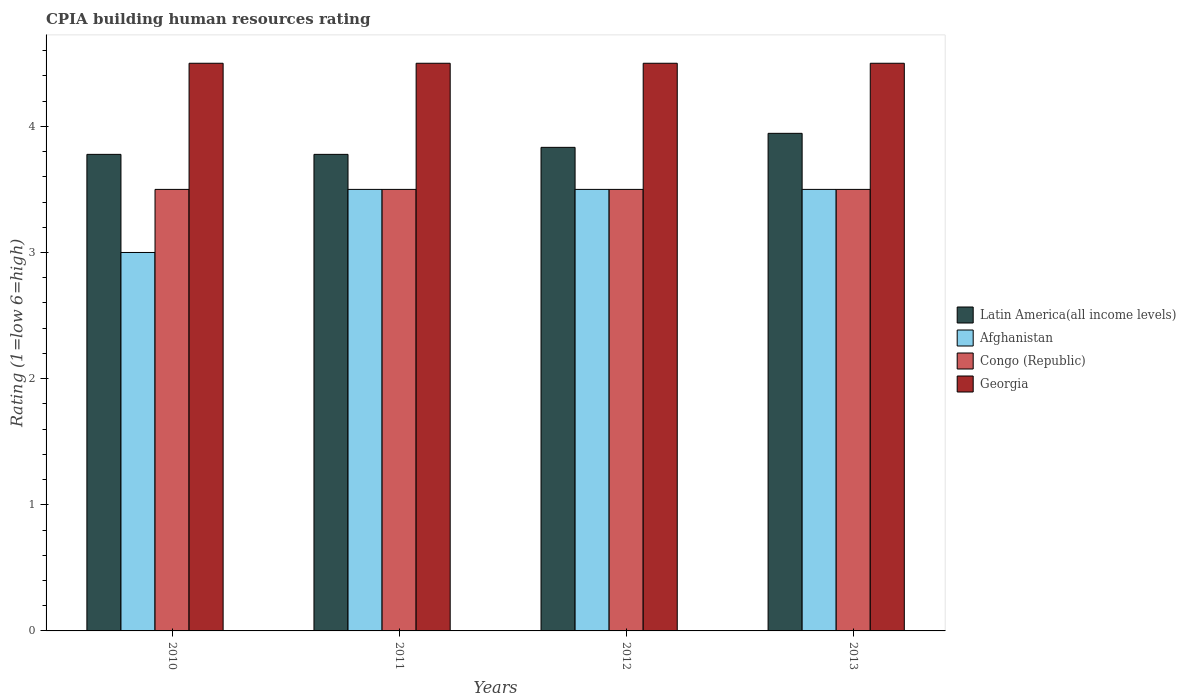What is the label of the 2nd group of bars from the left?
Ensure brevity in your answer.  2011. What is the CPIA rating in Afghanistan in 2012?
Provide a succinct answer. 3.5. Across all years, what is the maximum CPIA rating in Georgia?
Make the answer very short. 4.5. In which year was the CPIA rating in Latin America(all income levels) minimum?
Provide a succinct answer. 2010. What is the difference between the CPIA rating in Afghanistan in 2010 and the CPIA rating in Congo (Republic) in 2012?
Give a very brief answer. -0.5. What is the average CPIA rating in Afghanistan per year?
Keep it short and to the point. 3.38. In the year 2012, what is the difference between the CPIA rating in Latin America(all income levels) and CPIA rating in Congo (Republic)?
Your response must be concise. 0.33. In how many years, is the CPIA rating in Georgia greater than 4.2?
Offer a terse response. 4. What is the ratio of the CPIA rating in Congo (Republic) in 2011 to that in 2013?
Make the answer very short. 1. Is the CPIA rating in Congo (Republic) in 2012 less than that in 2013?
Your answer should be very brief. No. What is the difference between the highest and the lowest CPIA rating in Georgia?
Offer a terse response. 0. Is the sum of the CPIA rating in Georgia in 2012 and 2013 greater than the maximum CPIA rating in Congo (Republic) across all years?
Your answer should be compact. Yes. What does the 4th bar from the left in 2010 represents?
Provide a succinct answer. Georgia. What does the 1st bar from the right in 2013 represents?
Make the answer very short. Georgia. How many bars are there?
Your response must be concise. 16. Are all the bars in the graph horizontal?
Ensure brevity in your answer.  No. How many years are there in the graph?
Keep it short and to the point. 4. Does the graph contain any zero values?
Provide a short and direct response. No. How are the legend labels stacked?
Offer a terse response. Vertical. What is the title of the graph?
Your response must be concise. CPIA building human resources rating. Does "Russian Federation" appear as one of the legend labels in the graph?
Keep it short and to the point. No. What is the Rating (1=low 6=high) in Latin America(all income levels) in 2010?
Keep it short and to the point. 3.78. What is the Rating (1=low 6=high) in Congo (Republic) in 2010?
Provide a short and direct response. 3.5. What is the Rating (1=low 6=high) in Latin America(all income levels) in 2011?
Provide a succinct answer. 3.78. What is the Rating (1=low 6=high) of Georgia in 2011?
Offer a terse response. 4.5. What is the Rating (1=low 6=high) in Latin America(all income levels) in 2012?
Make the answer very short. 3.83. What is the Rating (1=low 6=high) in Georgia in 2012?
Your answer should be very brief. 4.5. What is the Rating (1=low 6=high) in Latin America(all income levels) in 2013?
Keep it short and to the point. 3.94. What is the Rating (1=low 6=high) in Afghanistan in 2013?
Make the answer very short. 3.5. Across all years, what is the maximum Rating (1=low 6=high) in Latin America(all income levels)?
Your response must be concise. 3.94. Across all years, what is the maximum Rating (1=low 6=high) of Afghanistan?
Provide a succinct answer. 3.5. Across all years, what is the maximum Rating (1=low 6=high) of Congo (Republic)?
Ensure brevity in your answer.  3.5. Across all years, what is the maximum Rating (1=low 6=high) of Georgia?
Your answer should be very brief. 4.5. Across all years, what is the minimum Rating (1=low 6=high) of Latin America(all income levels)?
Your answer should be compact. 3.78. Across all years, what is the minimum Rating (1=low 6=high) in Afghanistan?
Make the answer very short. 3. Across all years, what is the minimum Rating (1=low 6=high) of Congo (Republic)?
Your answer should be compact. 3.5. Across all years, what is the minimum Rating (1=low 6=high) of Georgia?
Keep it short and to the point. 4.5. What is the total Rating (1=low 6=high) in Latin America(all income levels) in the graph?
Make the answer very short. 15.33. What is the total Rating (1=low 6=high) in Afghanistan in the graph?
Your answer should be very brief. 13.5. What is the difference between the Rating (1=low 6=high) in Latin America(all income levels) in 2010 and that in 2011?
Offer a very short reply. 0. What is the difference between the Rating (1=low 6=high) in Afghanistan in 2010 and that in 2011?
Provide a succinct answer. -0.5. What is the difference between the Rating (1=low 6=high) of Latin America(all income levels) in 2010 and that in 2012?
Your answer should be very brief. -0.06. What is the difference between the Rating (1=low 6=high) in Afghanistan in 2010 and that in 2012?
Your response must be concise. -0.5. What is the difference between the Rating (1=low 6=high) in Georgia in 2010 and that in 2012?
Give a very brief answer. 0. What is the difference between the Rating (1=low 6=high) in Latin America(all income levels) in 2010 and that in 2013?
Give a very brief answer. -0.17. What is the difference between the Rating (1=low 6=high) of Afghanistan in 2010 and that in 2013?
Provide a short and direct response. -0.5. What is the difference between the Rating (1=low 6=high) of Georgia in 2010 and that in 2013?
Your response must be concise. 0. What is the difference between the Rating (1=low 6=high) of Latin America(all income levels) in 2011 and that in 2012?
Offer a very short reply. -0.06. What is the difference between the Rating (1=low 6=high) in Afghanistan in 2011 and that in 2012?
Your answer should be very brief. 0. What is the difference between the Rating (1=low 6=high) in Congo (Republic) in 2011 and that in 2012?
Your answer should be very brief. 0. What is the difference between the Rating (1=low 6=high) of Latin America(all income levels) in 2011 and that in 2013?
Ensure brevity in your answer.  -0.17. What is the difference between the Rating (1=low 6=high) of Congo (Republic) in 2011 and that in 2013?
Your answer should be compact. 0. What is the difference between the Rating (1=low 6=high) of Georgia in 2011 and that in 2013?
Make the answer very short. 0. What is the difference between the Rating (1=low 6=high) in Latin America(all income levels) in 2012 and that in 2013?
Ensure brevity in your answer.  -0.11. What is the difference between the Rating (1=low 6=high) of Afghanistan in 2012 and that in 2013?
Your response must be concise. 0. What is the difference between the Rating (1=low 6=high) in Latin America(all income levels) in 2010 and the Rating (1=low 6=high) in Afghanistan in 2011?
Give a very brief answer. 0.28. What is the difference between the Rating (1=low 6=high) in Latin America(all income levels) in 2010 and the Rating (1=low 6=high) in Congo (Republic) in 2011?
Provide a short and direct response. 0.28. What is the difference between the Rating (1=low 6=high) in Latin America(all income levels) in 2010 and the Rating (1=low 6=high) in Georgia in 2011?
Keep it short and to the point. -0.72. What is the difference between the Rating (1=low 6=high) in Afghanistan in 2010 and the Rating (1=low 6=high) in Georgia in 2011?
Keep it short and to the point. -1.5. What is the difference between the Rating (1=low 6=high) of Latin America(all income levels) in 2010 and the Rating (1=low 6=high) of Afghanistan in 2012?
Offer a very short reply. 0.28. What is the difference between the Rating (1=low 6=high) of Latin America(all income levels) in 2010 and the Rating (1=low 6=high) of Congo (Republic) in 2012?
Provide a short and direct response. 0.28. What is the difference between the Rating (1=low 6=high) of Latin America(all income levels) in 2010 and the Rating (1=low 6=high) of Georgia in 2012?
Offer a very short reply. -0.72. What is the difference between the Rating (1=low 6=high) of Afghanistan in 2010 and the Rating (1=low 6=high) of Georgia in 2012?
Your response must be concise. -1.5. What is the difference between the Rating (1=low 6=high) of Congo (Republic) in 2010 and the Rating (1=low 6=high) of Georgia in 2012?
Offer a very short reply. -1. What is the difference between the Rating (1=low 6=high) in Latin America(all income levels) in 2010 and the Rating (1=low 6=high) in Afghanistan in 2013?
Provide a succinct answer. 0.28. What is the difference between the Rating (1=low 6=high) in Latin America(all income levels) in 2010 and the Rating (1=low 6=high) in Congo (Republic) in 2013?
Give a very brief answer. 0.28. What is the difference between the Rating (1=low 6=high) of Latin America(all income levels) in 2010 and the Rating (1=low 6=high) of Georgia in 2013?
Your answer should be very brief. -0.72. What is the difference between the Rating (1=low 6=high) of Afghanistan in 2010 and the Rating (1=low 6=high) of Congo (Republic) in 2013?
Give a very brief answer. -0.5. What is the difference between the Rating (1=low 6=high) of Afghanistan in 2010 and the Rating (1=low 6=high) of Georgia in 2013?
Provide a succinct answer. -1.5. What is the difference between the Rating (1=low 6=high) of Latin America(all income levels) in 2011 and the Rating (1=low 6=high) of Afghanistan in 2012?
Ensure brevity in your answer.  0.28. What is the difference between the Rating (1=low 6=high) in Latin America(all income levels) in 2011 and the Rating (1=low 6=high) in Congo (Republic) in 2012?
Your answer should be compact. 0.28. What is the difference between the Rating (1=low 6=high) in Latin America(all income levels) in 2011 and the Rating (1=low 6=high) in Georgia in 2012?
Offer a very short reply. -0.72. What is the difference between the Rating (1=low 6=high) of Afghanistan in 2011 and the Rating (1=low 6=high) of Congo (Republic) in 2012?
Ensure brevity in your answer.  0. What is the difference between the Rating (1=low 6=high) of Congo (Republic) in 2011 and the Rating (1=low 6=high) of Georgia in 2012?
Offer a terse response. -1. What is the difference between the Rating (1=low 6=high) in Latin America(all income levels) in 2011 and the Rating (1=low 6=high) in Afghanistan in 2013?
Ensure brevity in your answer.  0.28. What is the difference between the Rating (1=low 6=high) of Latin America(all income levels) in 2011 and the Rating (1=low 6=high) of Congo (Republic) in 2013?
Offer a very short reply. 0.28. What is the difference between the Rating (1=low 6=high) in Latin America(all income levels) in 2011 and the Rating (1=low 6=high) in Georgia in 2013?
Offer a terse response. -0.72. What is the difference between the Rating (1=low 6=high) in Congo (Republic) in 2011 and the Rating (1=low 6=high) in Georgia in 2013?
Your answer should be very brief. -1. What is the difference between the Rating (1=low 6=high) in Latin America(all income levels) in 2012 and the Rating (1=low 6=high) in Congo (Republic) in 2013?
Your answer should be very brief. 0.33. What is the difference between the Rating (1=low 6=high) of Afghanistan in 2012 and the Rating (1=low 6=high) of Congo (Republic) in 2013?
Offer a terse response. 0. What is the difference between the Rating (1=low 6=high) of Afghanistan in 2012 and the Rating (1=low 6=high) of Georgia in 2013?
Your response must be concise. -1. What is the difference between the Rating (1=low 6=high) of Congo (Republic) in 2012 and the Rating (1=low 6=high) of Georgia in 2013?
Keep it short and to the point. -1. What is the average Rating (1=low 6=high) in Latin America(all income levels) per year?
Provide a succinct answer. 3.83. What is the average Rating (1=low 6=high) of Afghanistan per year?
Make the answer very short. 3.38. What is the average Rating (1=low 6=high) in Congo (Republic) per year?
Your response must be concise. 3.5. What is the average Rating (1=low 6=high) in Georgia per year?
Provide a succinct answer. 4.5. In the year 2010, what is the difference between the Rating (1=low 6=high) of Latin America(all income levels) and Rating (1=low 6=high) of Congo (Republic)?
Your answer should be very brief. 0.28. In the year 2010, what is the difference between the Rating (1=low 6=high) of Latin America(all income levels) and Rating (1=low 6=high) of Georgia?
Ensure brevity in your answer.  -0.72. In the year 2010, what is the difference between the Rating (1=low 6=high) of Afghanistan and Rating (1=low 6=high) of Georgia?
Offer a very short reply. -1.5. In the year 2011, what is the difference between the Rating (1=low 6=high) of Latin America(all income levels) and Rating (1=low 6=high) of Afghanistan?
Offer a terse response. 0.28. In the year 2011, what is the difference between the Rating (1=low 6=high) in Latin America(all income levels) and Rating (1=low 6=high) in Congo (Republic)?
Make the answer very short. 0.28. In the year 2011, what is the difference between the Rating (1=low 6=high) in Latin America(all income levels) and Rating (1=low 6=high) in Georgia?
Offer a terse response. -0.72. In the year 2011, what is the difference between the Rating (1=low 6=high) in Afghanistan and Rating (1=low 6=high) in Congo (Republic)?
Offer a very short reply. 0. In the year 2012, what is the difference between the Rating (1=low 6=high) of Latin America(all income levels) and Rating (1=low 6=high) of Afghanistan?
Your answer should be compact. 0.33. In the year 2012, what is the difference between the Rating (1=low 6=high) of Latin America(all income levels) and Rating (1=low 6=high) of Congo (Republic)?
Make the answer very short. 0.33. In the year 2012, what is the difference between the Rating (1=low 6=high) in Latin America(all income levels) and Rating (1=low 6=high) in Georgia?
Provide a succinct answer. -0.67. In the year 2012, what is the difference between the Rating (1=low 6=high) of Afghanistan and Rating (1=low 6=high) of Congo (Republic)?
Your answer should be compact. 0. In the year 2012, what is the difference between the Rating (1=low 6=high) of Afghanistan and Rating (1=low 6=high) of Georgia?
Your answer should be very brief. -1. In the year 2012, what is the difference between the Rating (1=low 6=high) in Congo (Republic) and Rating (1=low 6=high) in Georgia?
Your answer should be very brief. -1. In the year 2013, what is the difference between the Rating (1=low 6=high) in Latin America(all income levels) and Rating (1=low 6=high) in Afghanistan?
Your answer should be very brief. 0.44. In the year 2013, what is the difference between the Rating (1=low 6=high) in Latin America(all income levels) and Rating (1=low 6=high) in Congo (Republic)?
Offer a very short reply. 0.44. In the year 2013, what is the difference between the Rating (1=low 6=high) of Latin America(all income levels) and Rating (1=low 6=high) of Georgia?
Offer a terse response. -0.56. What is the ratio of the Rating (1=low 6=high) of Latin America(all income levels) in 2010 to that in 2011?
Your answer should be compact. 1. What is the ratio of the Rating (1=low 6=high) in Afghanistan in 2010 to that in 2011?
Offer a terse response. 0.86. What is the ratio of the Rating (1=low 6=high) in Latin America(all income levels) in 2010 to that in 2012?
Your answer should be very brief. 0.99. What is the ratio of the Rating (1=low 6=high) in Latin America(all income levels) in 2010 to that in 2013?
Ensure brevity in your answer.  0.96. What is the ratio of the Rating (1=low 6=high) in Congo (Republic) in 2010 to that in 2013?
Provide a short and direct response. 1. What is the ratio of the Rating (1=low 6=high) of Georgia in 2010 to that in 2013?
Your answer should be very brief. 1. What is the ratio of the Rating (1=low 6=high) of Latin America(all income levels) in 2011 to that in 2012?
Make the answer very short. 0.99. What is the ratio of the Rating (1=low 6=high) in Georgia in 2011 to that in 2012?
Keep it short and to the point. 1. What is the ratio of the Rating (1=low 6=high) in Latin America(all income levels) in 2011 to that in 2013?
Offer a terse response. 0.96. What is the ratio of the Rating (1=low 6=high) in Afghanistan in 2011 to that in 2013?
Provide a succinct answer. 1. What is the ratio of the Rating (1=low 6=high) in Latin America(all income levels) in 2012 to that in 2013?
Ensure brevity in your answer.  0.97. What is the ratio of the Rating (1=low 6=high) of Afghanistan in 2012 to that in 2013?
Provide a short and direct response. 1. What is the ratio of the Rating (1=low 6=high) in Georgia in 2012 to that in 2013?
Your response must be concise. 1. What is the difference between the highest and the second highest Rating (1=low 6=high) in Latin America(all income levels)?
Your response must be concise. 0.11. What is the difference between the highest and the second highest Rating (1=low 6=high) of Georgia?
Provide a short and direct response. 0. What is the difference between the highest and the lowest Rating (1=low 6=high) in Afghanistan?
Ensure brevity in your answer.  0.5. What is the difference between the highest and the lowest Rating (1=low 6=high) of Congo (Republic)?
Your answer should be very brief. 0. 